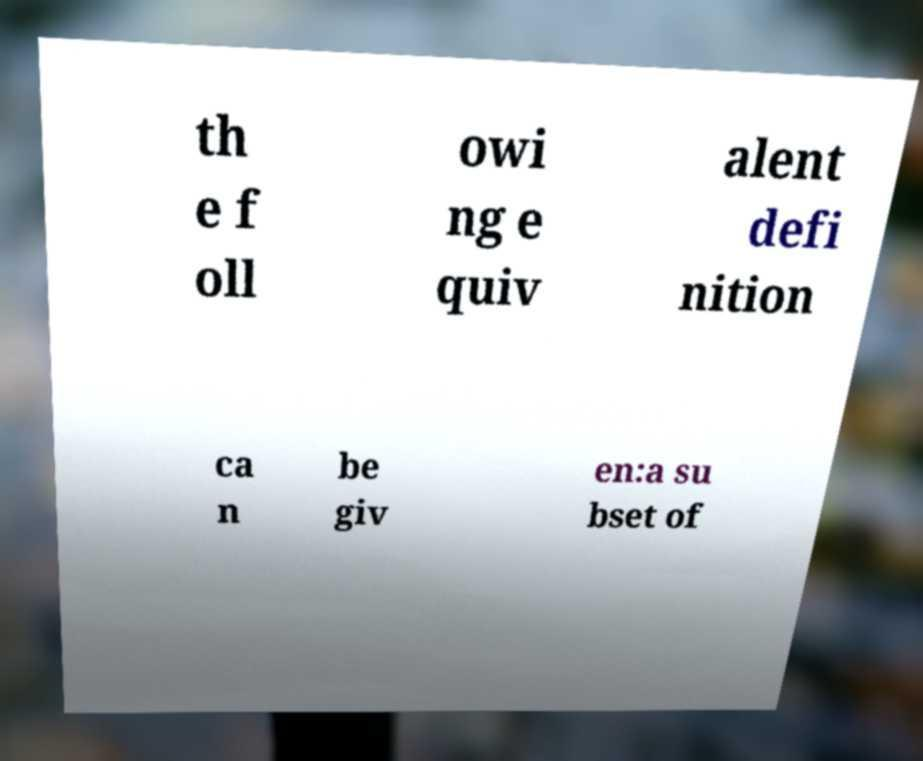For documentation purposes, I need the text within this image transcribed. Could you provide that? th e f oll owi ng e quiv alent defi nition ca n be giv en:a su bset of 